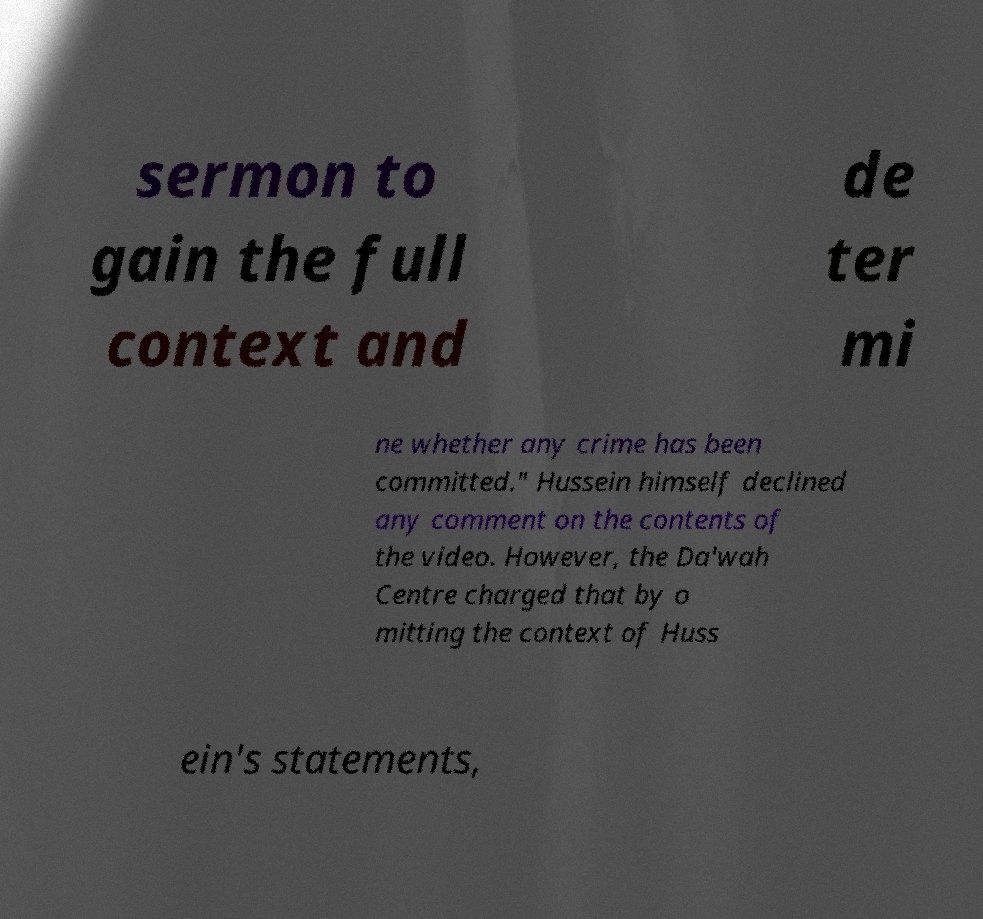Please identify and transcribe the text found in this image. sermon to gain the full context and de ter mi ne whether any crime has been committed." Hussein himself declined any comment on the contents of the video. However, the Da'wah Centre charged that by o mitting the context of Huss ein's statements, 